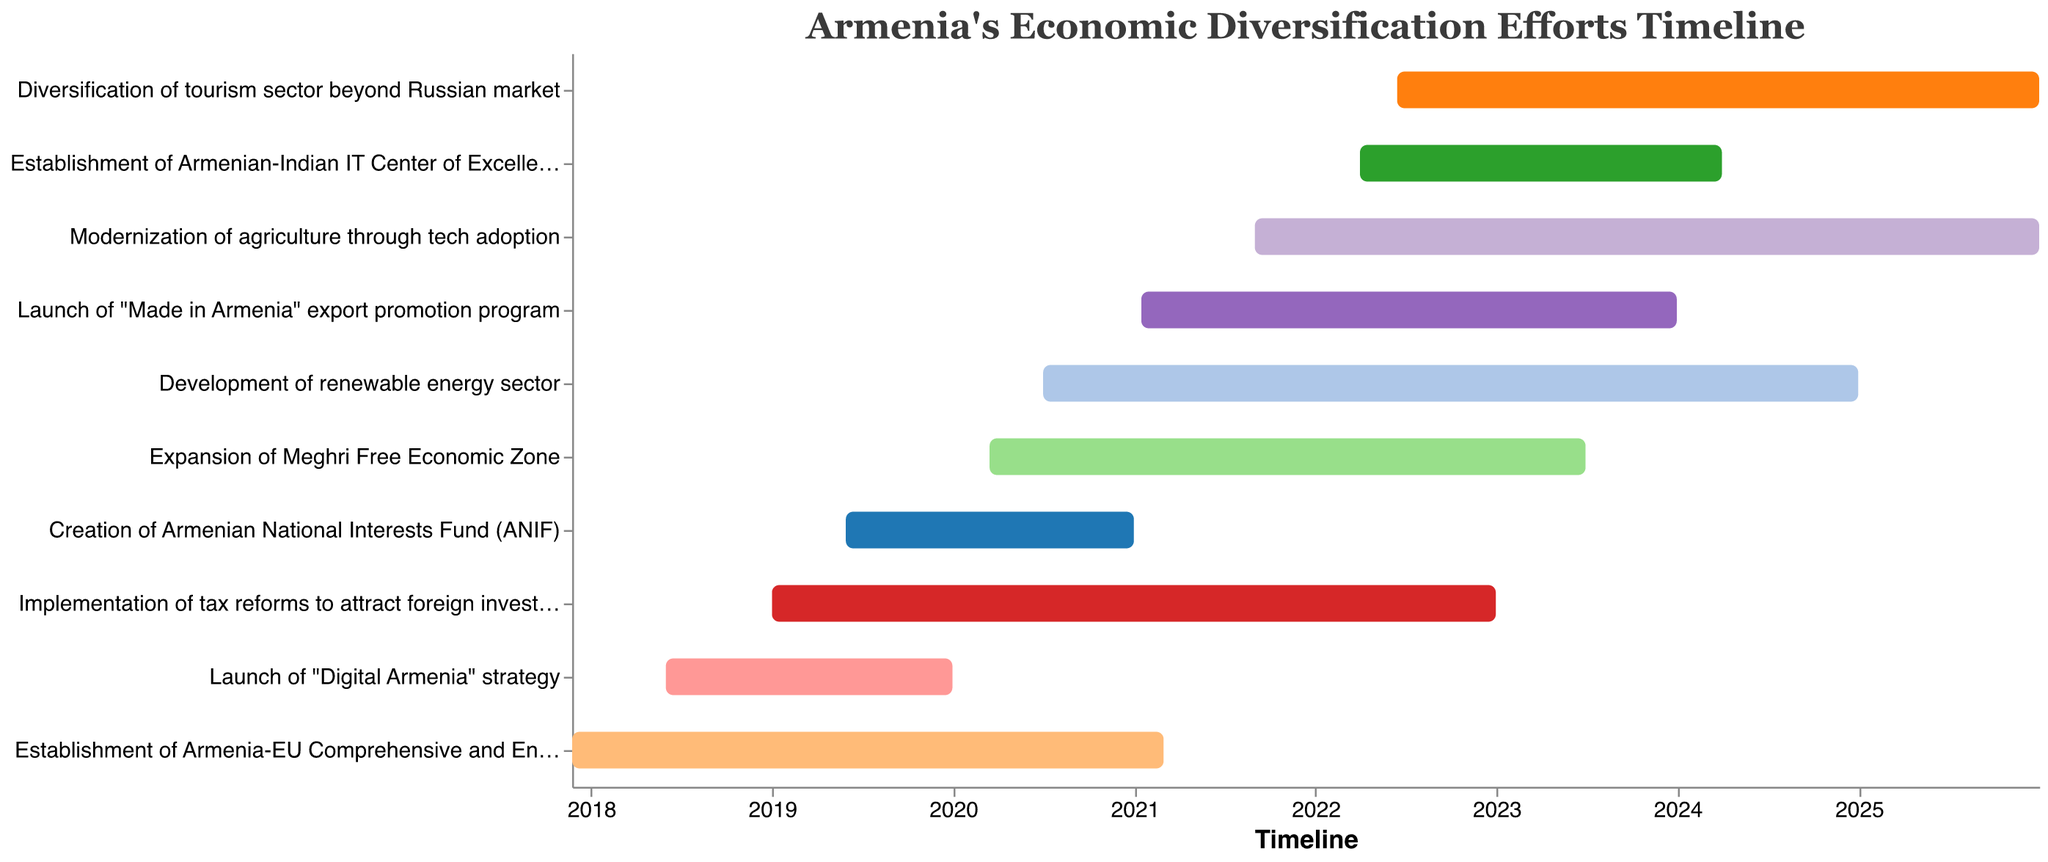What is the title of the Gantt chart? The title of the Gantt chart can be found at the top center of the plot. It reads "Armenia's Economic Diversification Efforts Timeline."
Answer: Armenia's Economic Diversification Efforts Timeline Which phase started earliest and which started latest? The earliest phase is listed at the top of the Gantt chart, which is the "Establishment of Armenia-EU Comprehensive and Enhanced Partnership Agreement" beginning on November 24, 2017. The latest phase is the "Diversification of tourism sector beyond Russian market," beginning on June 15, 2022.
Answer: Earliest: Establishment of Armenia-EU Comprehensive and Enhanced Partnership Agreement, Latest: Diversification of tourism sector beyond Russian market How many tasks are displayed in the Gantt chart? To determine how many tasks, count the number of unique entries (bars) listed vertically on the Gantt chart. There are 10 tasks represented.
Answer: 10 Which task had the longest duration? To find the task with the longest duration, compare the start and end dates for each task and find the one with the maximum duration. "Modernization of agriculture through tech adoption" starts on September 1, 2021, and ends on December 31, 2025, having the longest duration.
Answer: Modernization of agriculture through tech adoption During which years are all the tasks overlapping? To determine the overlapping years, observe the timeline on the X-axis and identify the years where all tasks' durations intersect. All tasks overlap in 2022 and 2023.
Answer: 2022 and 2023 Compare the durations of the "Launch of 'Digital Armenia' strategy" and the "Creation of Armenian National Interests Fund (ANIF)". Which task had a longer duration and by how many days? First, calculate the duration of both tasks. The "Launch of 'Digital Armenia' strategy" (June 1, 2018, to December 31, 2019) is 579 days. The "Creation of Armenian National Interests Fund (ANIF)" (May 30, 2019, to December 31, 2020) is 581 days. "Creation of Armenian National Interests Fund (ANIF)" is longer by 2 days.
Answer: ANIF by 2 days What color is used to represent the "Development of renewable energy sector"? To identify the color used, locate the task "Development of renewable energy sector" on the Gantt chart and note the color of its corresponding bar. The specific color may vary depending on the color scheme, but it will match a specific hue on the chart.
Answer: Specific to chart (not provided) Which two tasks were implemented concurrently from 2022 to 2023? Identify tasks with overlapping dates during the specific period from 2022 to 2023. The tasks "Implementation of tax reforms to attract foreign investment" (until 2022-12-31) and "Establishment of Armenian-Indian IT Center of Excellence" (from 2022-04-01) overlap within these dates.
Answer: Implementation of tax reforms to attract foreign investment & Establishment of Armenian-Indian IT Center of Excellence When did the expansion of Meghri Free Economic Zone start and when did it end? Locate the corresponding bar for "Expansion of Meghri Free Economic Zone". The start date is March 15, 2020, and the end date is June 30, 2023.
Answer: Start: March 15, 2020, End: June 30, 2023 Which tasks were aimed at diversifying Armenia's technology and digital landscape? Identify tasks that explicitly mention technology and digital enhancement. "Launch of 'Digital Armenia' strategy" and "Establishment of Armenian-Indian IT Center of Excellence" are the relevant tasks.
Answer: Launch of 'Digital Armenia' strategy, Establishment of Armenian-Indian IT Center of Excellence 